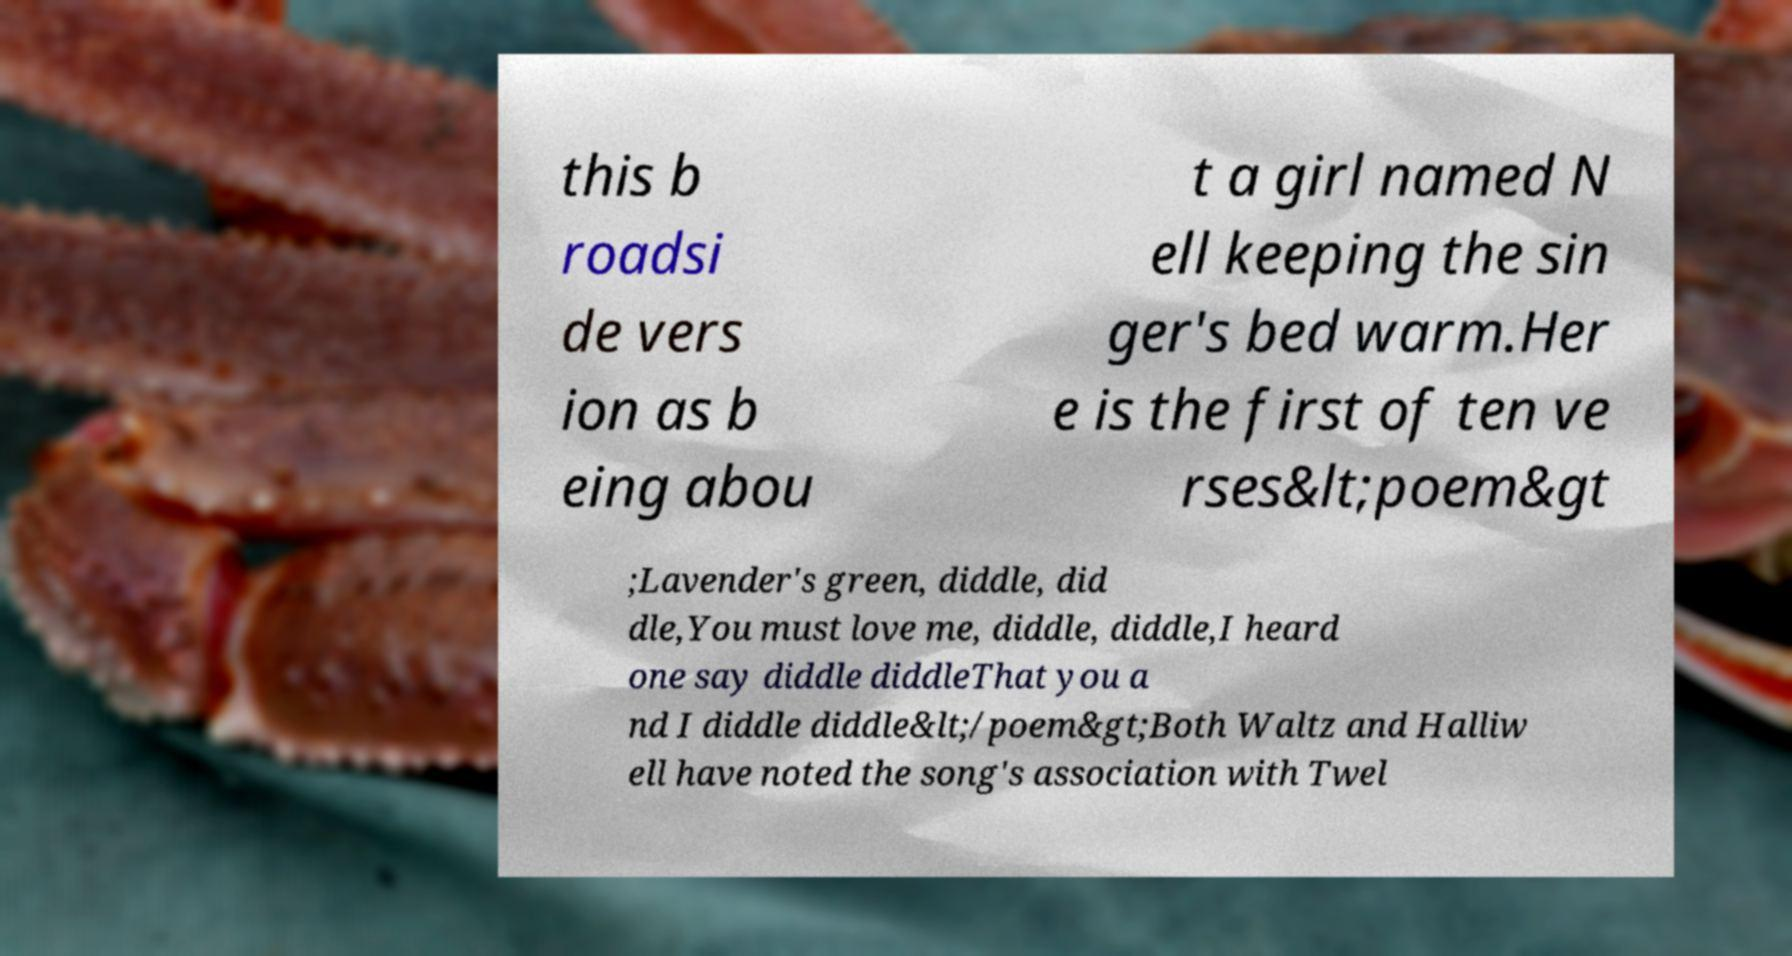Please read and relay the text visible in this image. What does it say? this b roadsi de vers ion as b eing abou t a girl named N ell keeping the sin ger's bed warm.Her e is the first of ten ve rses&lt;poem&gt ;Lavender's green, diddle, did dle,You must love me, diddle, diddle,I heard one say diddle diddleThat you a nd I diddle diddle&lt;/poem&gt;Both Waltz and Halliw ell have noted the song's association with Twel 